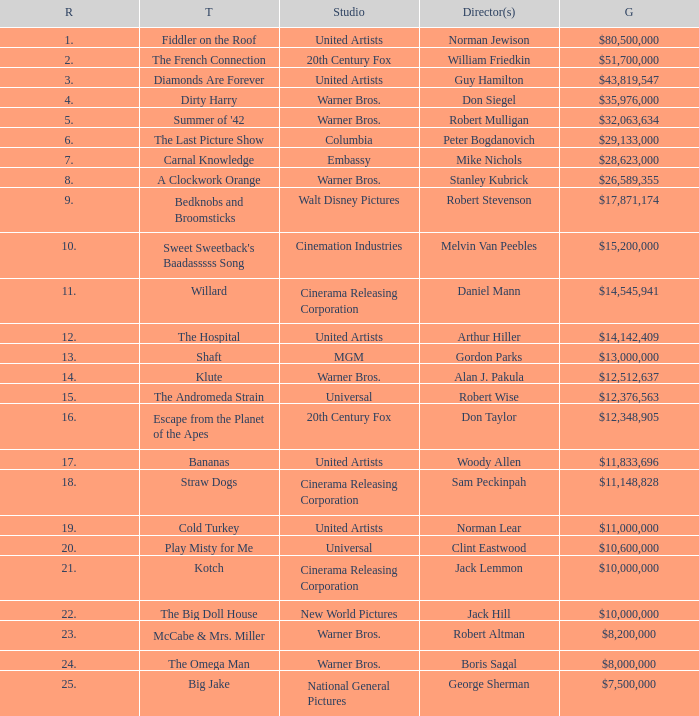What is the rank of The Big Doll House? 22.0. 